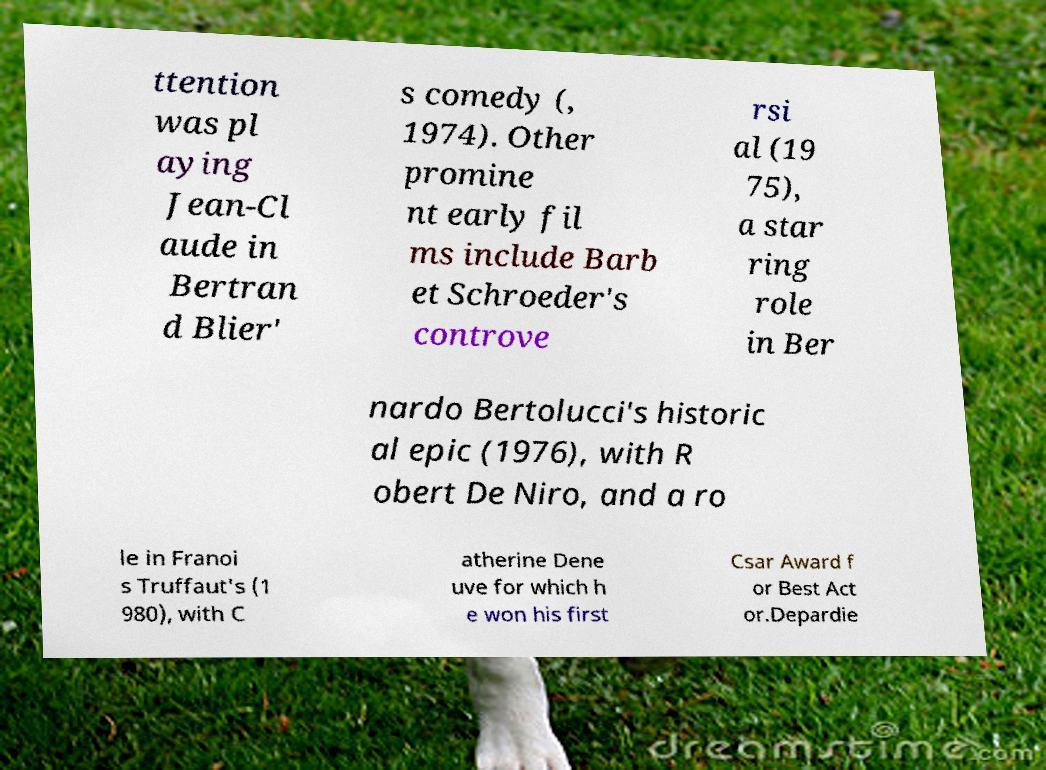Can you accurately transcribe the text from the provided image for me? ttention was pl aying Jean-Cl aude in Bertran d Blier' s comedy (, 1974). Other promine nt early fil ms include Barb et Schroeder's controve rsi al (19 75), a star ring role in Ber nardo Bertolucci's historic al epic (1976), with R obert De Niro, and a ro le in Franoi s Truffaut's (1 980), with C atherine Dene uve for which h e won his first Csar Award f or Best Act or.Depardie 